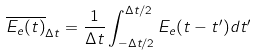<formula> <loc_0><loc_0><loc_500><loc_500>\overline { E _ { e } ( t ) } _ { \Delta t } = \frac { 1 } { \Delta t } \int _ { - \Delta t / 2 } ^ { \Delta t / 2 } E _ { e } ( t - t ^ { \prime } ) d t ^ { \prime }</formula> 